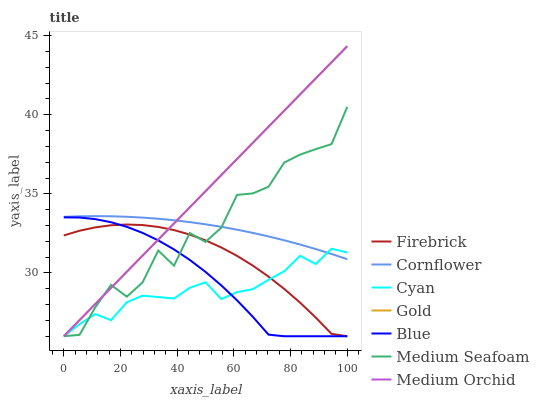Does Cyan have the minimum area under the curve?
Answer yes or no. Yes. Does Gold have the maximum area under the curve?
Answer yes or no. Yes. Does Cornflower have the minimum area under the curve?
Answer yes or no. No. Does Cornflower have the maximum area under the curve?
Answer yes or no. No. Is Medium Orchid the smoothest?
Answer yes or no. Yes. Is Medium Seafoam the roughest?
Answer yes or no. Yes. Is Cornflower the smoothest?
Answer yes or no. No. Is Cornflower the roughest?
Answer yes or no. No. Does Blue have the lowest value?
Answer yes or no. Yes. Does Cornflower have the lowest value?
Answer yes or no. No. Does Gold have the highest value?
Answer yes or no. Yes. Does Cornflower have the highest value?
Answer yes or no. No. Is Firebrick less than Cornflower?
Answer yes or no. Yes. Is Cornflower greater than Firebrick?
Answer yes or no. Yes. Does Cornflower intersect Medium Seafoam?
Answer yes or no. Yes. Is Cornflower less than Medium Seafoam?
Answer yes or no. No. Is Cornflower greater than Medium Seafoam?
Answer yes or no. No. Does Firebrick intersect Cornflower?
Answer yes or no. No. 